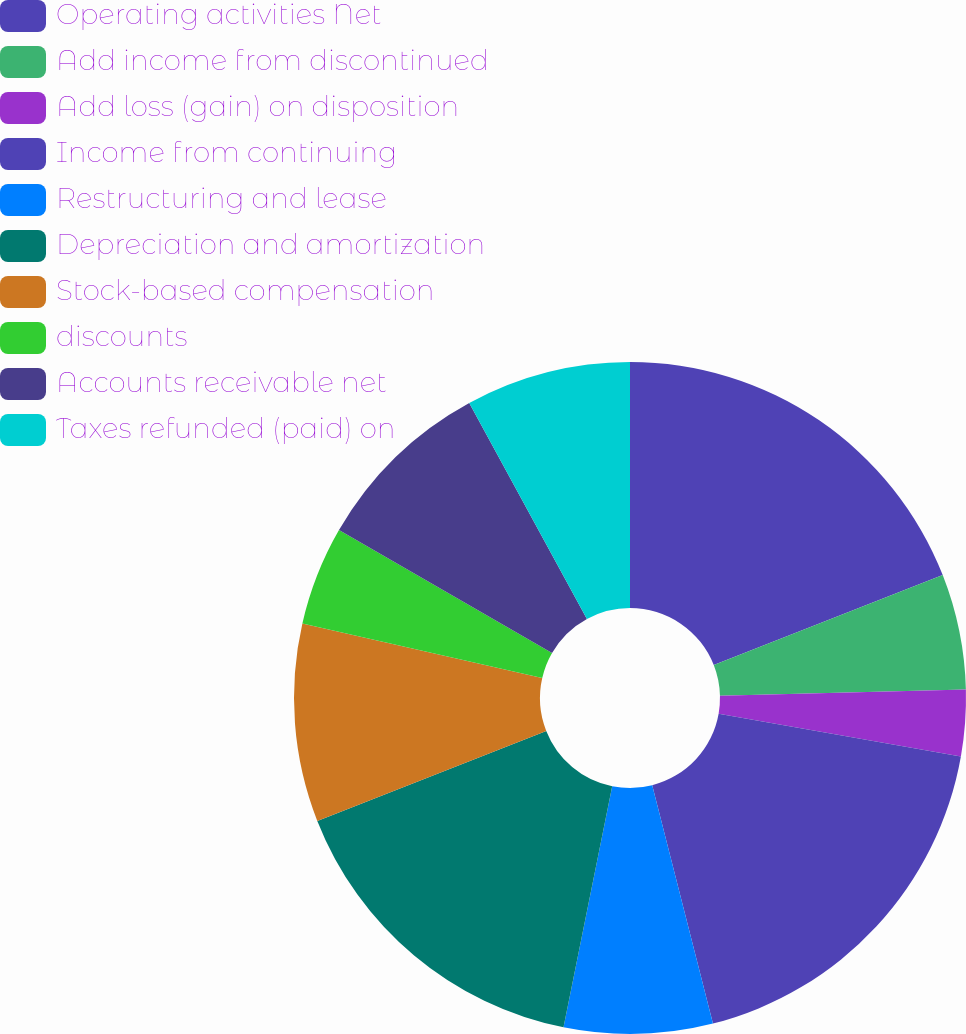Convert chart. <chart><loc_0><loc_0><loc_500><loc_500><pie_chart><fcel>Operating activities Net<fcel>Add income from discontinued<fcel>Add loss (gain) on disposition<fcel>Income from continuing<fcel>Restructuring and lease<fcel>Depreciation and amortization<fcel>Stock-based compensation<fcel>discounts<fcel>Accounts receivable net<fcel>Taxes refunded (paid) on<nl><fcel>19.04%<fcel>5.56%<fcel>3.18%<fcel>18.25%<fcel>7.14%<fcel>15.87%<fcel>9.52%<fcel>4.77%<fcel>8.73%<fcel>7.94%<nl></chart> 